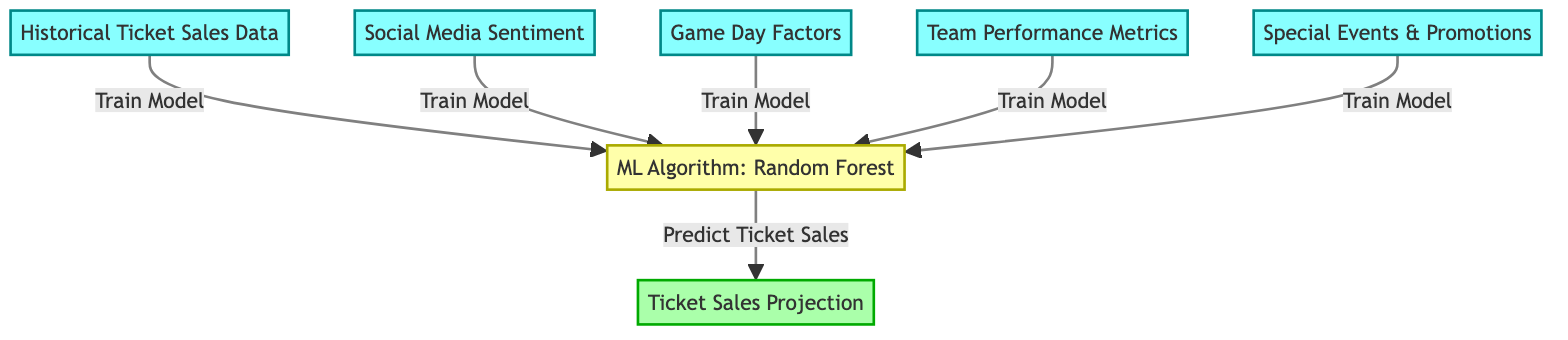What is the first input node in the diagram? The first input node listed in the diagram is "Historical Ticket Sales Data". This is identified as the node labeled with the number 1 at the top of the diagram.
Answer: Historical Ticket Sales Data How many input nodes are there? The diagram shows five distinct input nodes, each labeled accordingly. They are numbered 1 through 5.
Answer: Five Which algorithm is used for ticket sales projection? The algorithm utilized in the diagram for making projections is "Random Forest". This is directly mentioned in the node labeled with the number 6.
Answer: Random Forest What is the last step in the flow from input to output? The last step in the flow diagram is shown as "Predict Ticket Sales", which connects the algorithm node to the output node labeled "Ticket Sales Projection". This indicates that the model predicts ticket sales after training.
Answer: Predict Ticket Sales What are the main types of data included as input? The main types of data are "Historical Ticket Sales Data", "Social Media Sentiment", "Game Day Factors", "Team Performance Metrics", and "Special Events & Promotions". These represent various influences on ticket sales.
Answer: Five types of data Which input node has a direct connection to the algorithm node? All five input nodes ("Historical Ticket Sales Data", "Social Media Sentiment", "Game Day Factors", "Team Performance Metrics", and "Special Events & Promotions") have direct connections to the algorithm node. There are no other nodes in between.
Answer: All input nodes How does the model make predictions? The model makes predictions by training on data from all input nodes, ultimately using the trained machine learning algorithm (Random Forest) to output the ticket sales projection. This is indicated by the arrows leading to the algorithm and then to the projection output.
Answer: By training on all input data What is the output of the diagram? The output of the machine learning diagram is "Ticket Sales Projection". This is represented as the final node in the flowchart, numbered as 7.
Answer: Ticket Sales Projection 